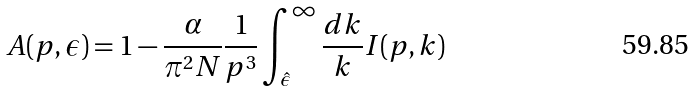Convert formula to latex. <formula><loc_0><loc_0><loc_500><loc_500>A ( p , \epsilon ) = 1 - \frac { \alpha } { \pi ^ { 2 } N } \frac { 1 } { p ^ { 3 } } \int _ { \hat { \epsilon } } ^ { \infty } \frac { d k } { k } I ( p , k )</formula> 